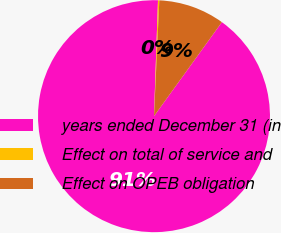<chart> <loc_0><loc_0><loc_500><loc_500><pie_chart><fcel>years ended December 31 (in<fcel>Effect on total of service and<fcel>Effect on OPEB obligation<nl><fcel>90.6%<fcel>0.18%<fcel>9.22%<nl></chart> 